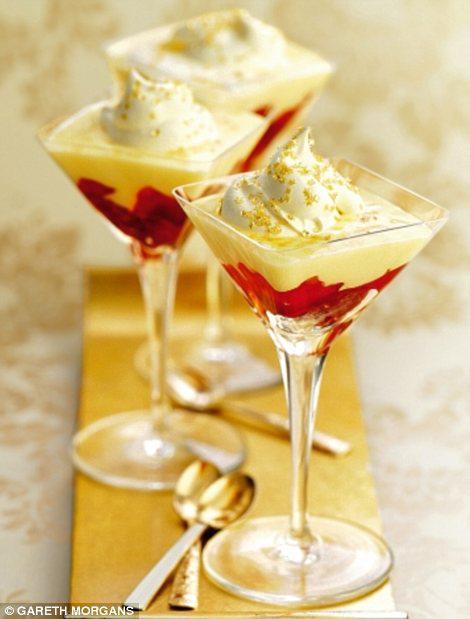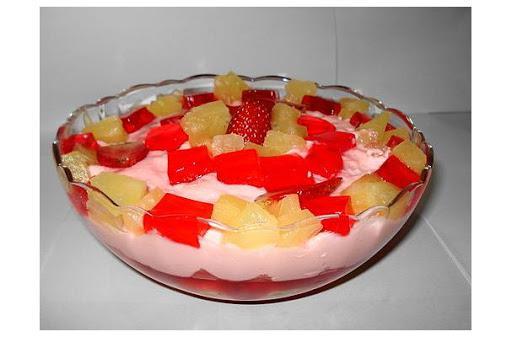The first image is the image on the left, the second image is the image on the right. Considering the images on both sides, is "An image shows spoons next to a trifle dessert." valid? Answer yes or no. Yes. 